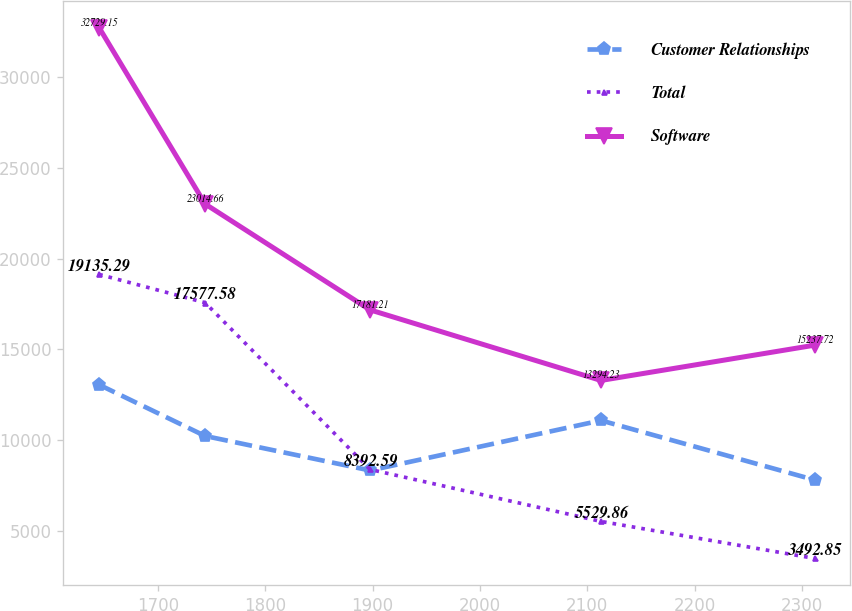Convert chart to OTSL. <chart><loc_0><loc_0><loc_500><loc_500><line_chart><ecel><fcel>Customer Relationships<fcel>Total<fcel>Software<nl><fcel>1645.24<fcel>13058.2<fcel>19135.3<fcel>32729.2<nl><fcel>1744.02<fcel>10235.2<fcel>17577.6<fcel>23014.7<nl><fcel>1897.61<fcel>8337.76<fcel>8392.59<fcel>17181.2<nl><fcel>2112.7<fcel>11091<fcel>5529.86<fcel>13294.2<nl><fcel>2311.64<fcel>7813.26<fcel>3492.85<fcel>15237.7<nl></chart> 